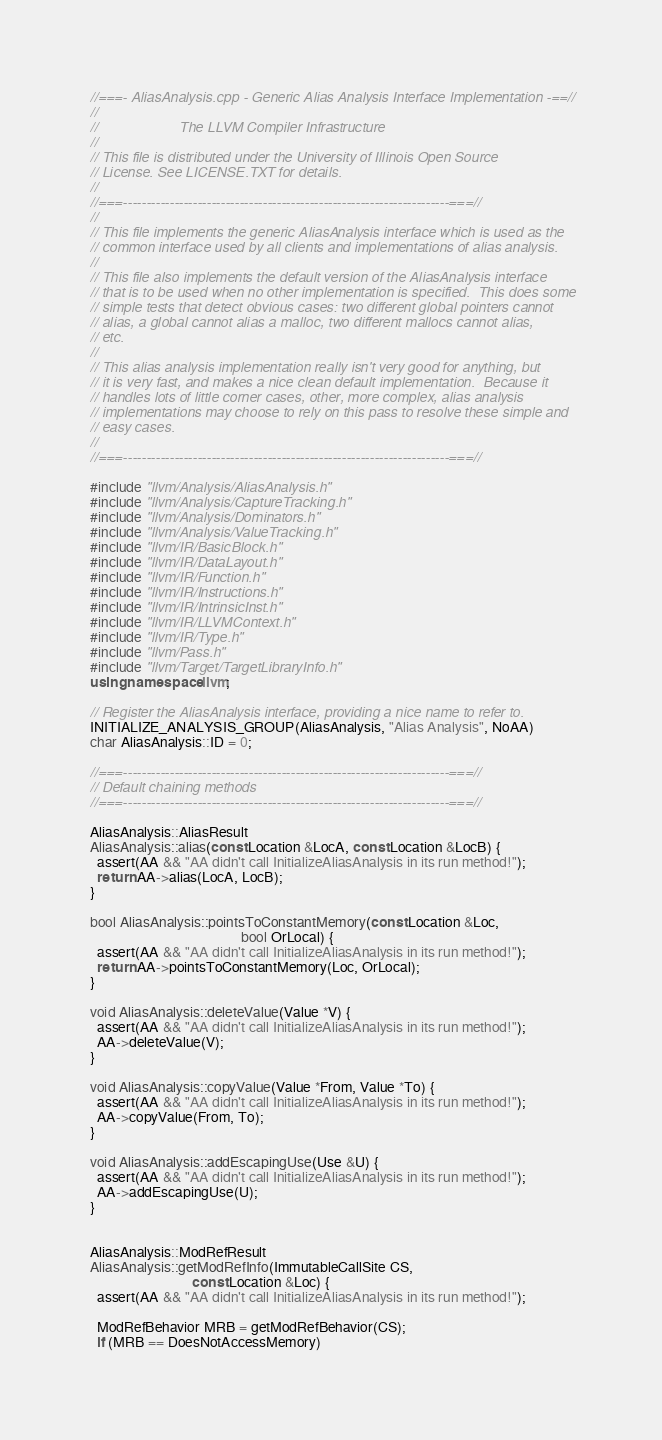<code> <loc_0><loc_0><loc_500><loc_500><_C++_>//===- AliasAnalysis.cpp - Generic Alias Analysis Interface Implementation -==//
//
//                     The LLVM Compiler Infrastructure
//
// This file is distributed under the University of Illinois Open Source
// License. See LICENSE.TXT for details.
//
//===----------------------------------------------------------------------===//
//
// This file implements the generic AliasAnalysis interface which is used as the
// common interface used by all clients and implementations of alias analysis.
//
// This file also implements the default version of the AliasAnalysis interface
// that is to be used when no other implementation is specified.  This does some
// simple tests that detect obvious cases: two different global pointers cannot
// alias, a global cannot alias a malloc, two different mallocs cannot alias,
// etc.
//
// This alias analysis implementation really isn't very good for anything, but
// it is very fast, and makes a nice clean default implementation.  Because it
// handles lots of little corner cases, other, more complex, alias analysis
// implementations may choose to rely on this pass to resolve these simple and
// easy cases.
//
//===----------------------------------------------------------------------===//

#include "llvm/Analysis/AliasAnalysis.h"
#include "llvm/Analysis/CaptureTracking.h"
#include "llvm/Analysis/Dominators.h"
#include "llvm/Analysis/ValueTracking.h"
#include "llvm/IR/BasicBlock.h"
#include "llvm/IR/DataLayout.h"
#include "llvm/IR/Function.h"
#include "llvm/IR/Instructions.h"
#include "llvm/IR/IntrinsicInst.h"
#include "llvm/IR/LLVMContext.h"
#include "llvm/IR/Type.h"
#include "llvm/Pass.h"
#include "llvm/Target/TargetLibraryInfo.h"
using namespace llvm;

// Register the AliasAnalysis interface, providing a nice name to refer to.
INITIALIZE_ANALYSIS_GROUP(AliasAnalysis, "Alias Analysis", NoAA)
char AliasAnalysis::ID = 0;

//===----------------------------------------------------------------------===//
// Default chaining methods
//===----------------------------------------------------------------------===//

AliasAnalysis::AliasResult
AliasAnalysis::alias(const Location &LocA, const Location &LocB) {
  assert(AA && "AA didn't call InitializeAliasAnalysis in its run method!");
  return AA->alias(LocA, LocB);
}

bool AliasAnalysis::pointsToConstantMemory(const Location &Loc,
                                           bool OrLocal) {
  assert(AA && "AA didn't call InitializeAliasAnalysis in its run method!");
  return AA->pointsToConstantMemory(Loc, OrLocal);
}

void AliasAnalysis::deleteValue(Value *V) {
  assert(AA && "AA didn't call InitializeAliasAnalysis in its run method!");
  AA->deleteValue(V);
}

void AliasAnalysis::copyValue(Value *From, Value *To) {
  assert(AA && "AA didn't call InitializeAliasAnalysis in its run method!");
  AA->copyValue(From, To);
}

void AliasAnalysis::addEscapingUse(Use &U) {
  assert(AA && "AA didn't call InitializeAliasAnalysis in its run method!");
  AA->addEscapingUse(U);
}


AliasAnalysis::ModRefResult
AliasAnalysis::getModRefInfo(ImmutableCallSite CS,
                             const Location &Loc) {
  assert(AA && "AA didn't call InitializeAliasAnalysis in its run method!");

  ModRefBehavior MRB = getModRefBehavior(CS);
  if (MRB == DoesNotAccessMemory)</code> 